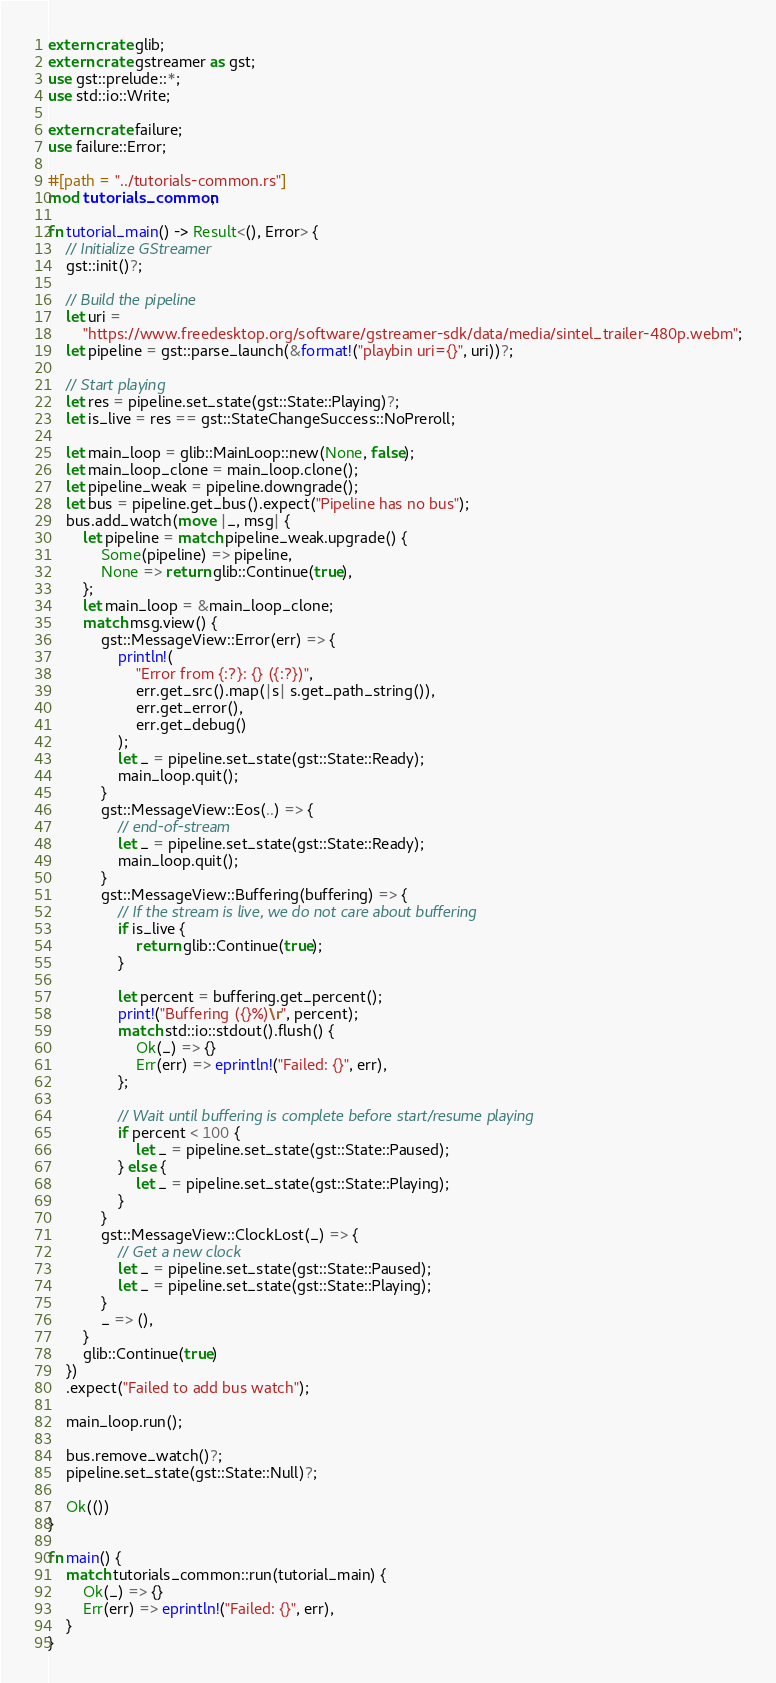<code> <loc_0><loc_0><loc_500><loc_500><_Rust_>extern crate glib;
extern crate gstreamer as gst;
use gst::prelude::*;
use std::io::Write;

extern crate failure;
use failure::Error;

#[path = "../tutorials-common.rs"]
mod tutorials_common;

fn tutorial_main() -> Result<(), Error> {
    // Initialize GStreamer
    gst::init()?;

    // Build the pipeline
    let uri =
        "https://www.freedesktop.org/software/gstreamer-sdk/data/media/sintel_trailer-480p.webm";
    let pipeline = gst::parse_launch(&format!("playbin uri={}", uri))?;

    // Start playing
    let res = pipeline.set_state(gst::State::Playing)?;
    let is_live = res == gst::StateChangeSuccess::NoPreroll;

    let main_loop = glib::MainLoop::new(None, false);
    let main_loop_clone = main_loop.clone();
    let pipeline_weak = pipeline.downgrade();
    let bus = pipeline.get_bus().expect("Pipeline has no bus");
    bus.add_watch(move |_, msg| {
        let pipeline = match pipeline_weak.upgrade() {
            Some(pipeline) => pipeline,
            None => return glib::Continue(true),
        };
        let main_loop = &main_loop_clone;
        match msg.view() {
            gst::MessageView::Error(err) => {
                println!(
                    "Error from {:?}: {} ({:?})",
                    err.get_src().map(|s| s.get_path_string()),
                    err.get_error(),
                    err.get_debug()
                );
                let _ = pipeline.set_state(gst::State::Ready);
                main_loop.quit();
            }
            gst::MessageView::Eos(..) => {
                // end-of-stream
                let _ = pipeline.set_state(gst::State::Ready);
                main_loop.quit();
            }
            gst::MessageView::Buffering(buffering) => {
                // If the stream is live, we do not care about buffering
                if is_live {
                    return glib::Continue(true);
                }

                let percent = buffering.get_percent();
                print!("Buffering ({}%)\r", percent);
                match std::io::stdout().flush() {
                    Ok(_) => {}
                    Err(err) => eprintln!("Failed: {}", err),
                };

                // Wait until buffering is complete before start/resume playing
                if percent < 100 {
                    let _ = pipeline.set_state(gst::State::Paused);
                } else {
                    let _ = pipeline.set_state(gst::State::Playing);
                }
            }
            gst::MessageView::ClockLost(_) => {
                // Get a new clock
                let _ = pipeline.set_state(gst::State::Paused);
                let _ = pipeline.set_state(gst::State::Playing);
            }
            _ => (),
        }
        glib::Continue(true)
    })
    .expect("Failed to add bus watch");

    main_loop.run();

    bus.remove_watch()?;
    pipeline.set_state(gst::State::Null)?;

    Ok(())
}

fn main() {
    match tutorials_common::run(tutorial_main) {
        Ok(_) => {}
        Err(err) => eprintln!("Failed: {}", err),
    }
}
</code> 